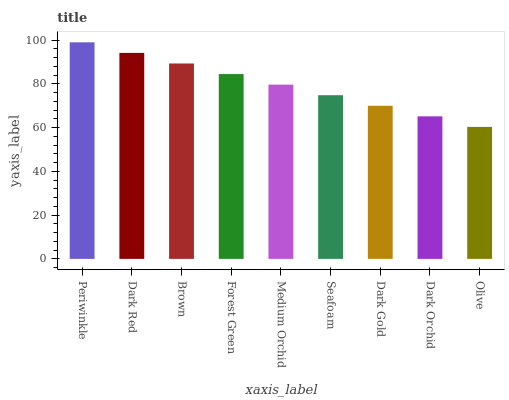Is Olive the minimum?
Answer yes or no. Yes. Is Periwinkle the maximum?
Answer yes or no. Yes. Is Dark Red the minimum?
Answer yes or no. No. Is Dark Red the maximum?
Answer yes or no. No. Is Periwinkle greater than Dark Red?
Answer yes or no. Yes. Is Dark Red less than Periwinkle?
Answer yes or no. Yes. Is Dark Red greater than Periwinkle?
Answer yes or no. No. Is Periwinkle less than Dark Red?
Answer yes or no. No. Is Medium Orchid the high median?
Answer yes or no. Yes. Is Medium Orchid the low median?
Answer yes or no. Yes. Is Periwinkle the high median?
Answer yes or no. No. Is Dark Orchid the low median?
Answer yes or no. No. 